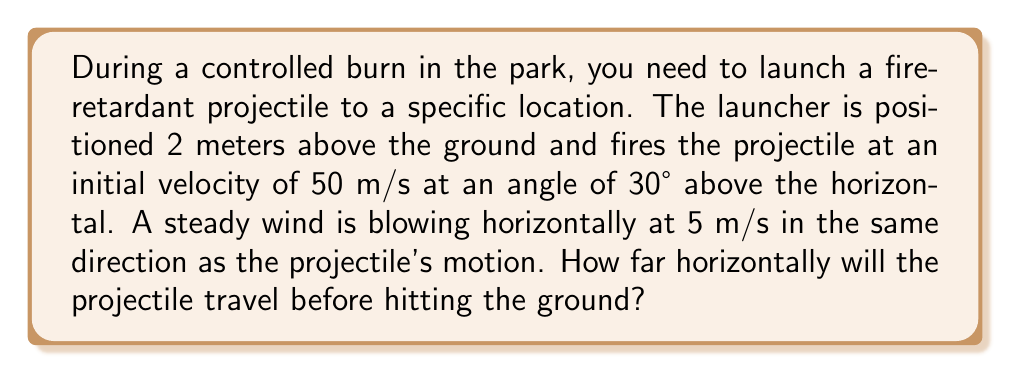What is the answer to this math problem? Let's approach this step-by-step:

1) First, we need to consider the equations of motion for a projectile under the influence of wind. The wind only affects the horizontal motion.

2) For the horizontal motion:
   $$x = (v_0 \cos\theta + v_w)t$$
   Where $v_0$ is the initial velocity, $\theta$ is the launch angle, $v_w$ is the wind velocity, and $t$ is the time of flight.

3) For the vertical motion:
   $$y = h_0 + (v_0 \sin\theta)t - \frac{1}{2}gt^2$$
   Where $h_0$ is the initial height and $g$ is the acceleration due to gravity (9.8 m/s²).

4) We need to find the time when the projectile hits the ground, i.e., when $y = 0$:
   $$0 = 2 + (50 \sin30°)t - \frac{1}{2}(9.8)t^2$$

5) Simplifying:
   $$4.9t^2 - 25t - 2 = 0$$

6) Solving this quadratic equation:
   $$t = \frac{25 + \sqrt{625 + 39.2}}{9.8} \approx 3.67 \text{ seconds}$$

7) Now we can use this time in the horizontal equation:
   $$x = (50 \cos30° + 5)(3.67)$$

8) Calculating:
   $$x = (43.3 + 5)(3.67) \approx 177.3 \text{ meters}$$
Answer: 177.3 meters 